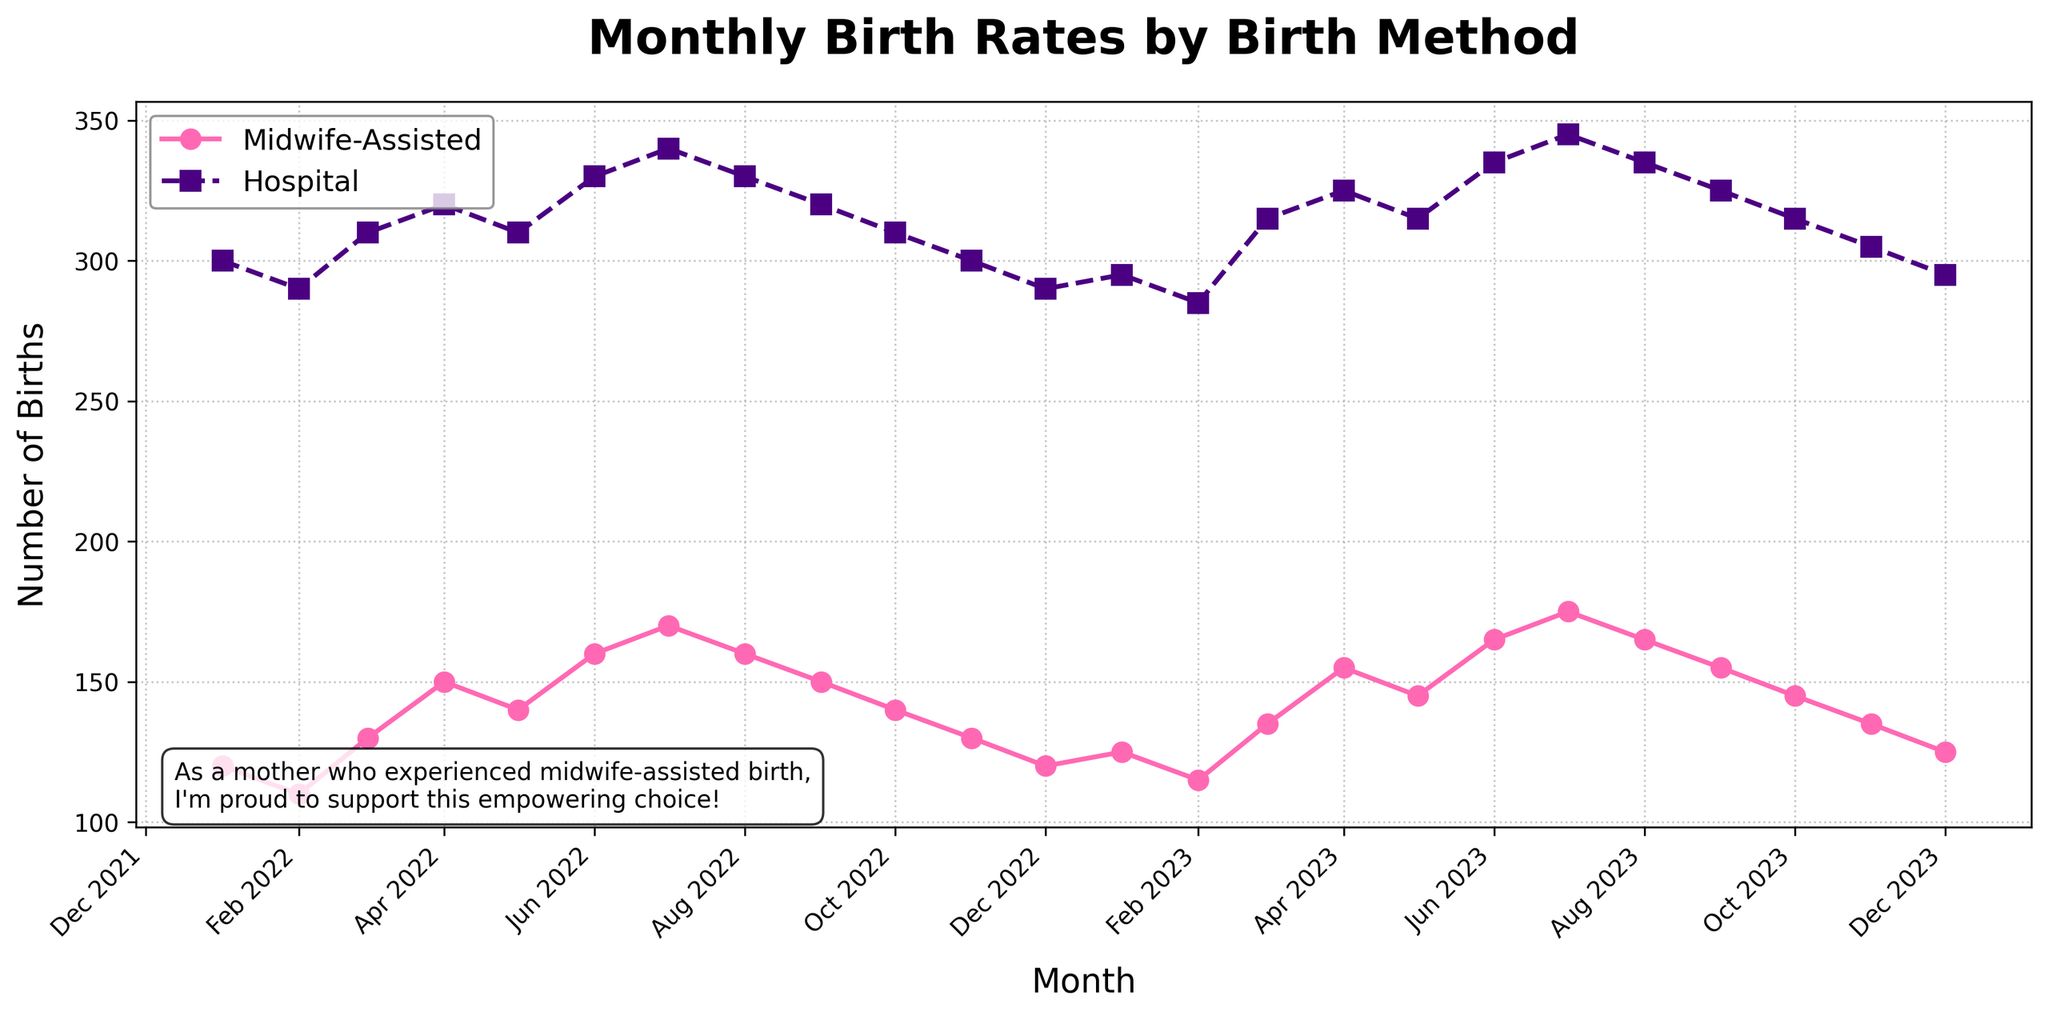What is the title of the plot? Look at the top of the figure, where the title is typically placed. The title is 'Monthly Birth Rates by Birth Method'.
Answer: Monthly Birth Rates by Birth Method What time period does the data cover? The x-axis shows the data points with monthly labels from January 2022 to December 2023.
Answer: January 2022 to December 2023 What color is used to represent midwife-assisted births? Examine the plot's legend; the color for midwife-assisted births is indicated there.
Answer: Pink How many data points are there for each birth method? Count the number of markers or data points along one of the plotted lines; the plot shows monthly data for two years, so there are 24 data points.
Answer: 24 In which month and year was the highest number of midwife-assisted births recorded? Identify the peak point on the pink line representing midwife-assisted births. The highest point occurs around July 2023 with 175 births.
Answer: July 2023 What is the difference in hospital births between December 2022 and December 2023? Locate the points for hospital births in December 2022 and December 2023; subtract the value for December 2022 (290) from that for December 2023 (295).
Answer: 5 Which month in 2023 saw the highest number of hospital births? Follow the indigo line for hospital births in 2023 and identify the peak, which occurs in July 2023, with 345 births.
Answer: July 2023 Are midwife-assisted births generally increasing, decreasing, or stable over the time period? Examine the trend of the pink line over the plot's duration. The line shows a general increasing trend.
Answer: Increasing By how much did midwife-assisted births increase from January 2022 to July 2023? Compare the number of midwife-assisted births in January 2022 (120) with July 2023 (175). The difference is 175 - 120.
Answer: 55 Which birth method showed more variability in the number of births month to month? Compare the fluctuations of both lines. The indigo line representing hospital births shows more month-to-month variability than the pink line representing midwife-assisted births.
Answer: Hospital 